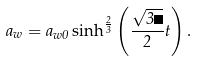<formula> <loc_0><loc_0><loc_500><loc_500>a _ { w } = a _ { w 0 } \, { \sinh } ^ { \frac { 2 } { 3 } } \left ( \frac { \sqrt { 3 \Lambda } } { 2 } t \right ) .</formula> 